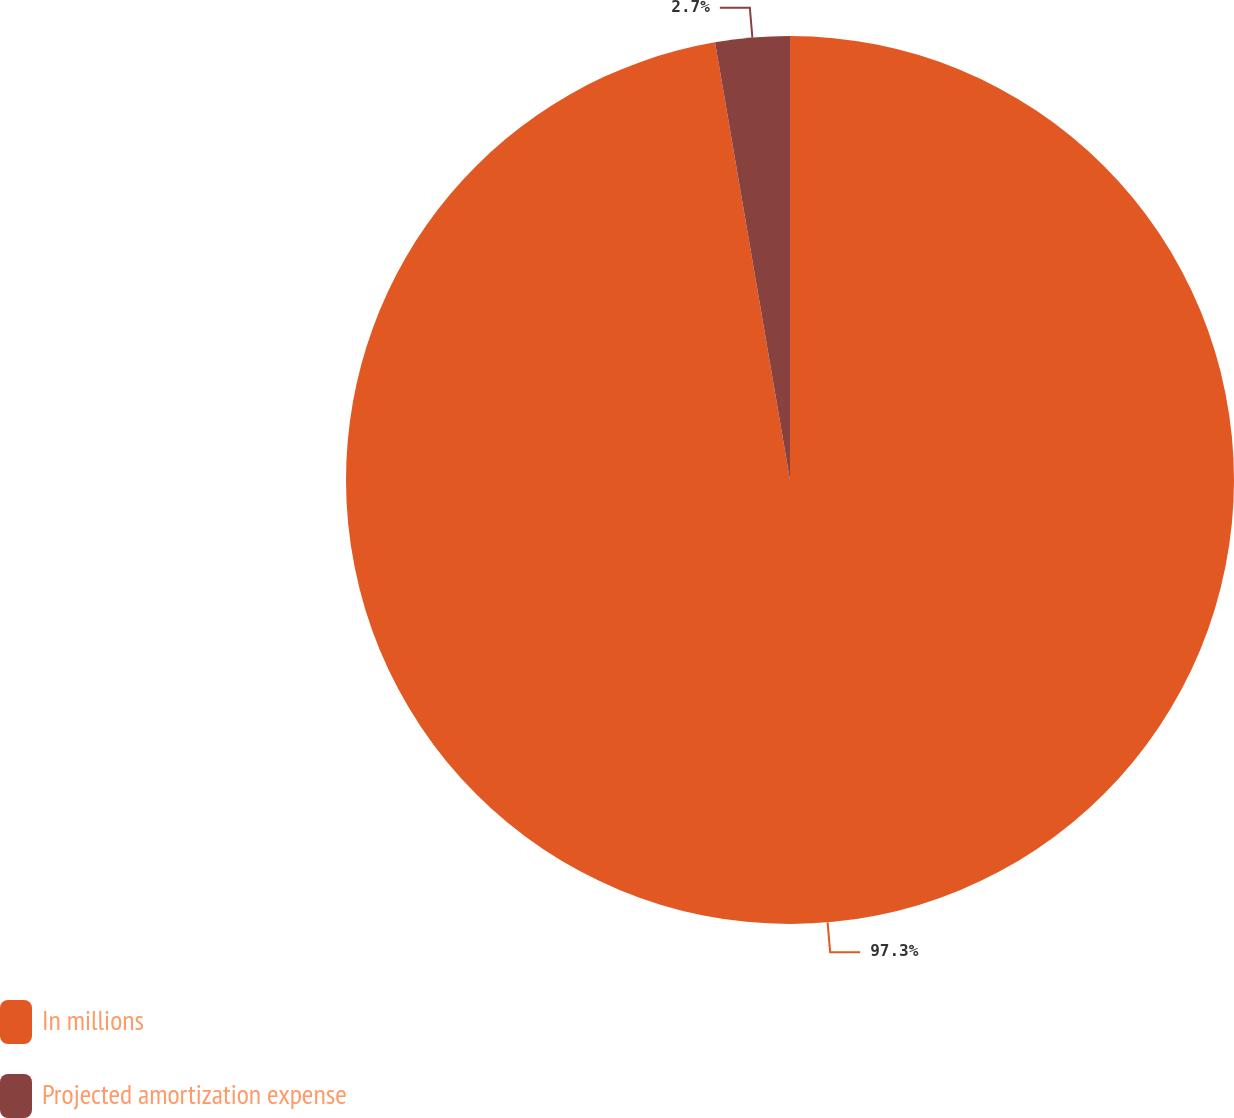Convert chart. <chart><loc_0><loc_0><loc_500><loc_500><pie_chart><fcel>In millions<fcel>Projected amortization expense<nl><fcel>97.3%<fcel>2.7%<nl></chart> 